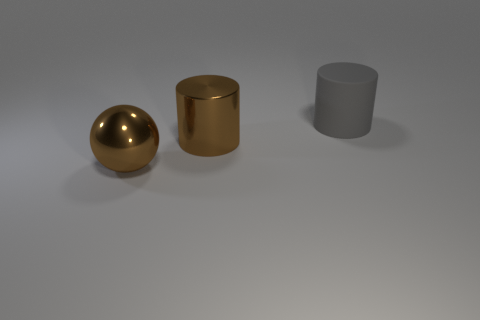Is there a gray cylinder that has the same material as the brown ball?
Your answer should be very brief. No. How many cylinders are large shiny things or large objects?
Ensure brevity in your answer.  2. There is a metal object right of the shiny ball; is there a large brown thing behind it?
Offer a terse response. No. Is the number of brown cylinders less than the number of brown metal things?
Ensure brevity in your answer.  Yes. How many other gray matte things are the same shape as the big gray rubber object?
Your answer should be very brief. 0. How many green objects are metallic spheres or large metallic objects?
Give a very brief answer. 0. There is a cylinder that is left of the cylinder right of the large brown cylinder; how big is it?
Your response must be concise. Large. How many cylinders are the same size as the rubber thing?
Offer a very short reply. 1. Is the gray matte cylinder the same size as the metal ball?
Provide a succinct answer. Yes. There is a object that is on the left side of the large gray cylinder and to the right of the large brown metal sphere; what is its size?
Offer a terse response. Large. 